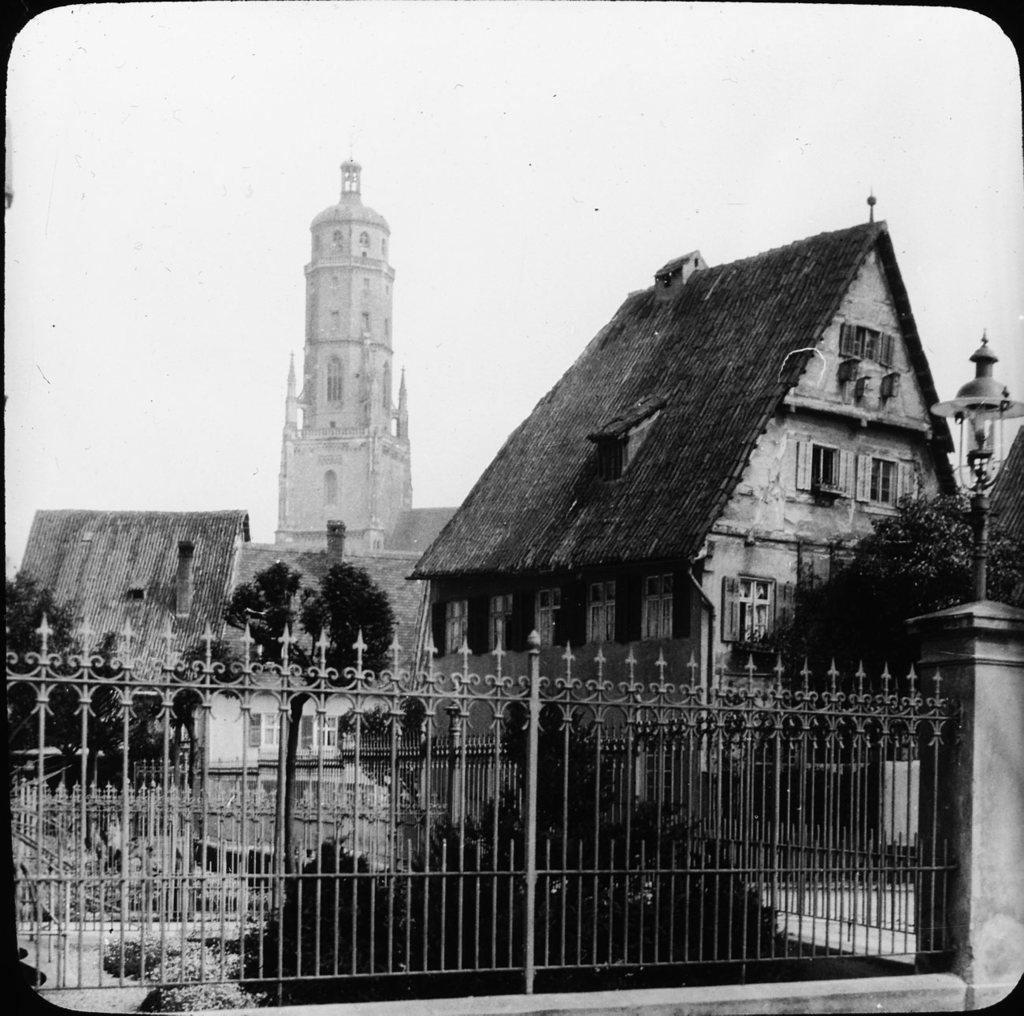What is the color scheme of the image? The image is black and white. What can be seen in the middle of the image? There are buildings and trees in the middle of the image. What is located at the bottom of the image? There is a fence at the bottom of the image. What is visible at the top of the image? The sky is visible at the top of the image. What type of toothbrush is visible in the image? There is no toothbrush present in the image. What route does the train take in the image? There is no train present in the image, so it is not possible to determine a route. 